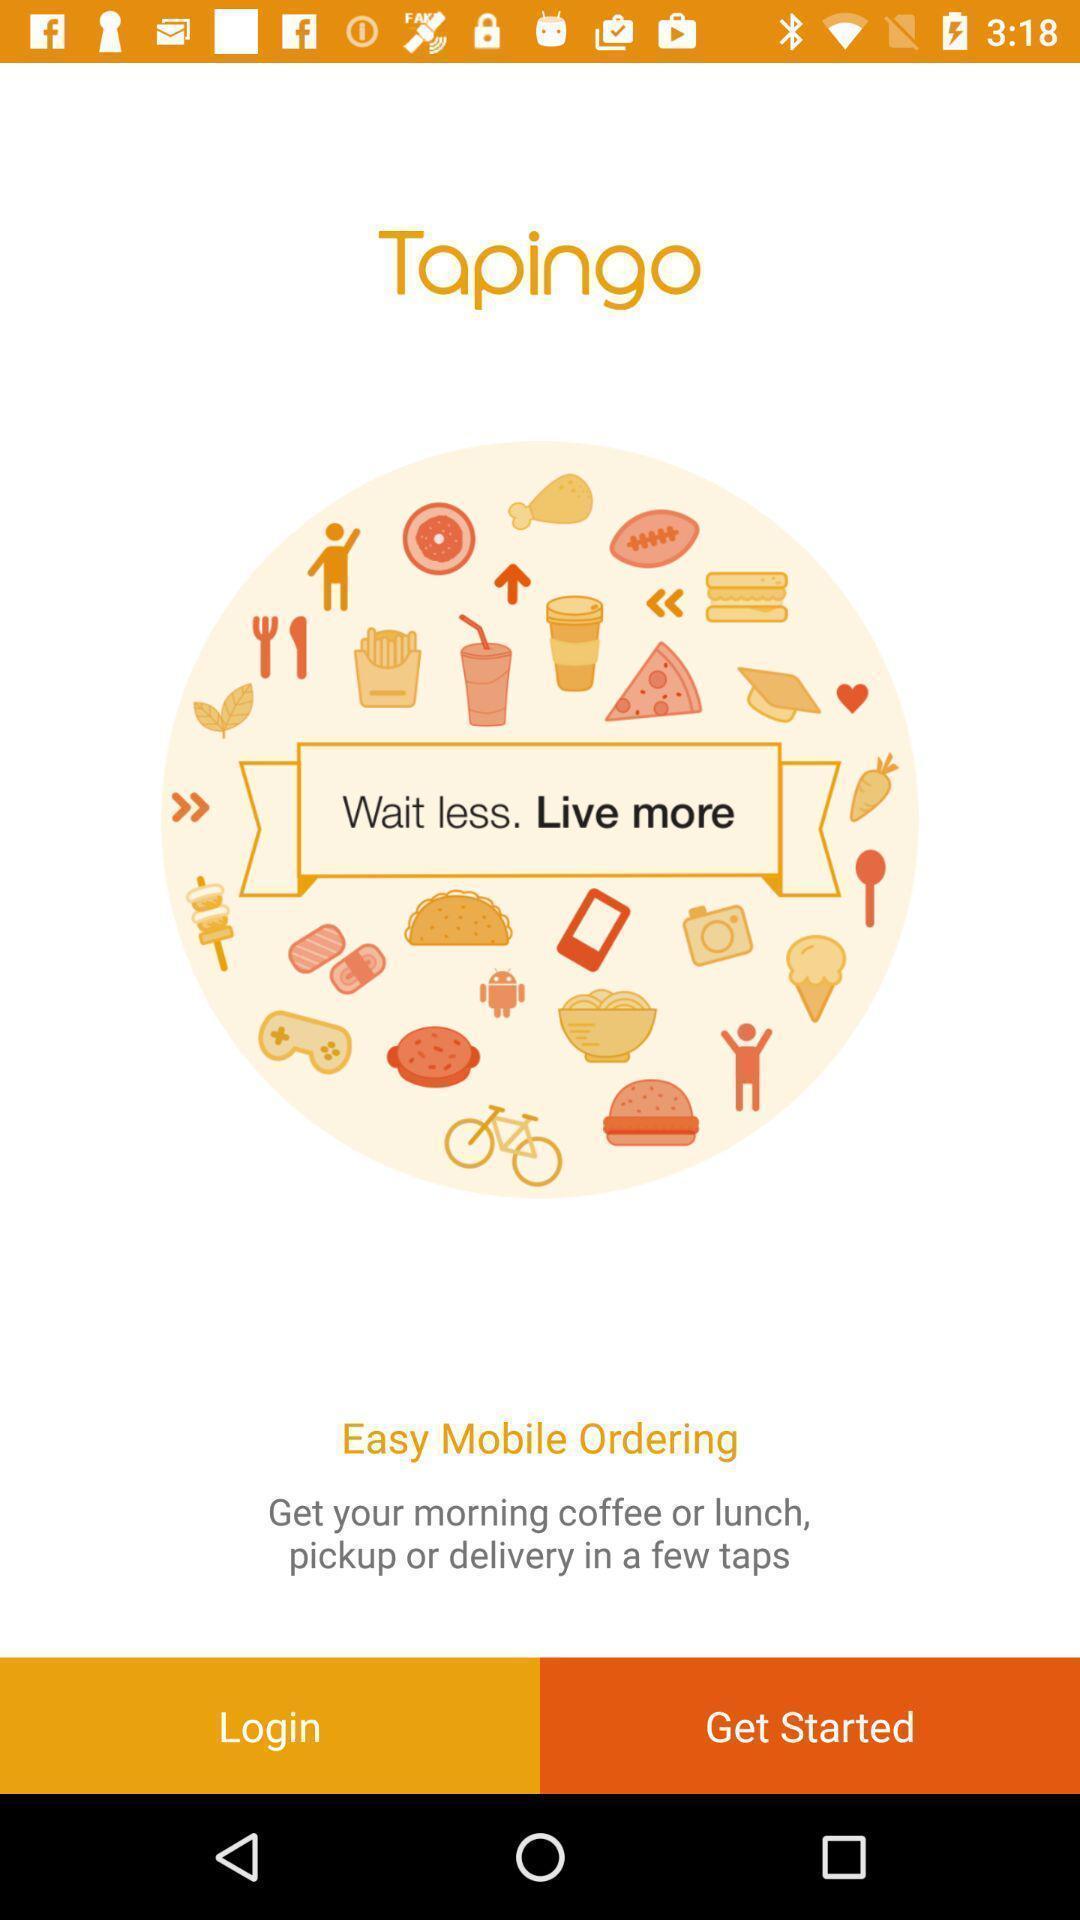Provide a textual representation of this image. Welcome page of an ordering app. 